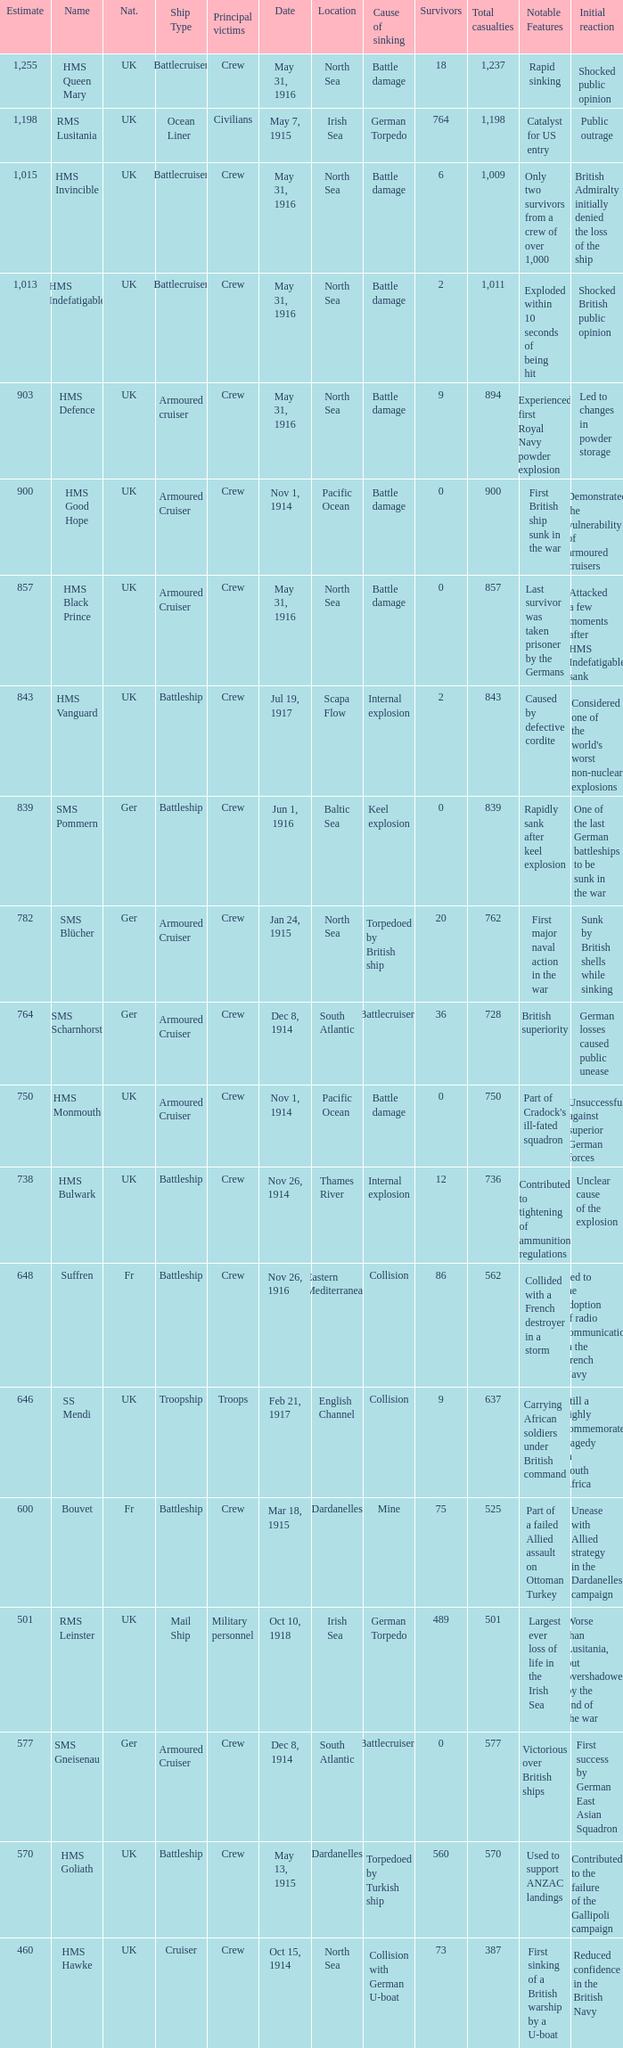What is the origin of the ship when the primary casualties are civilians? UK. 